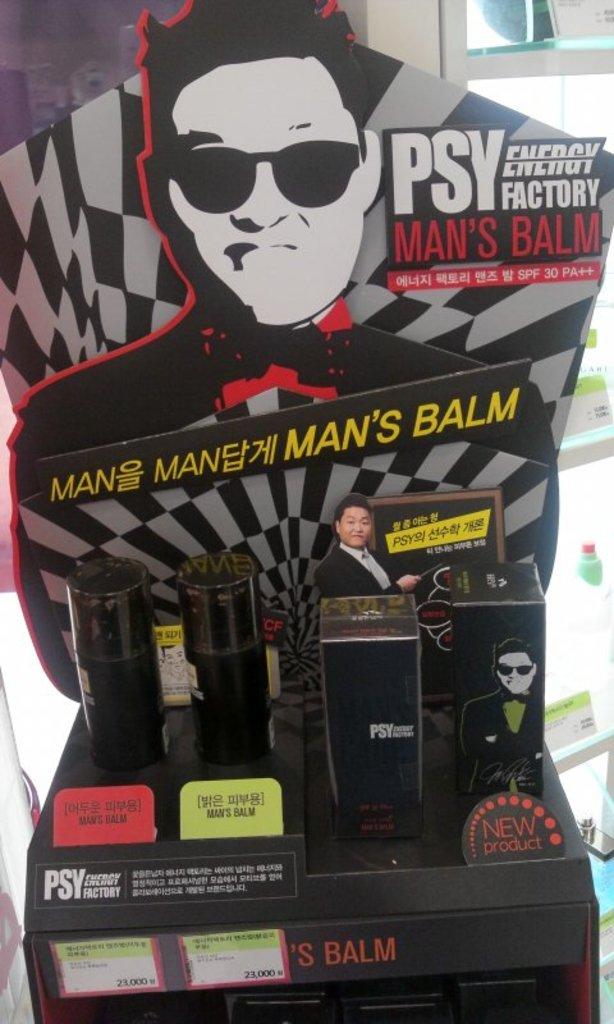What is the product?
Your answer should be compact. Man's balm. 